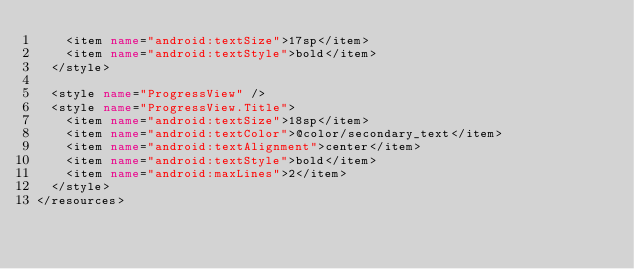<code> <loc_0><loc_0><loc_500><loc_500><_XML_>    <item name="android:textSize">17sp</item>
    <item name="android:textStyle">bold</item>
  </style>

  <style name="ProgressView" />
  <style name="ProgressView.Title">
    <item name="android:textSize">18sp</item>
    <item name="android:textColor">@color/secondary_text</item>
    <item name="android:textAlignment">center</item>
    <item name="android:textStyle">bold</item>
    <item name="android:maxLines">2</item>
  </style>
</resources>
</code> 